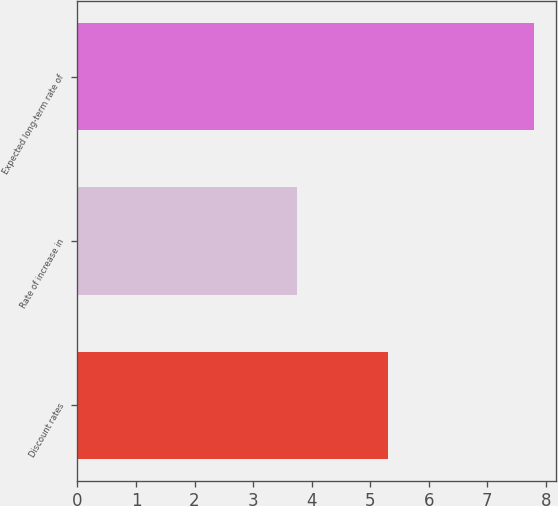Convert chart to OTSL. <chart><loc_0><loc_0><loc_500><loc_500><bar_chart><fcel>Discount rates<fcel>Rate of increase in<fcel>Expected long-term rate of<nl><fcel>5.3<fcel>3.75<fcel>7.79<nl></chart> 